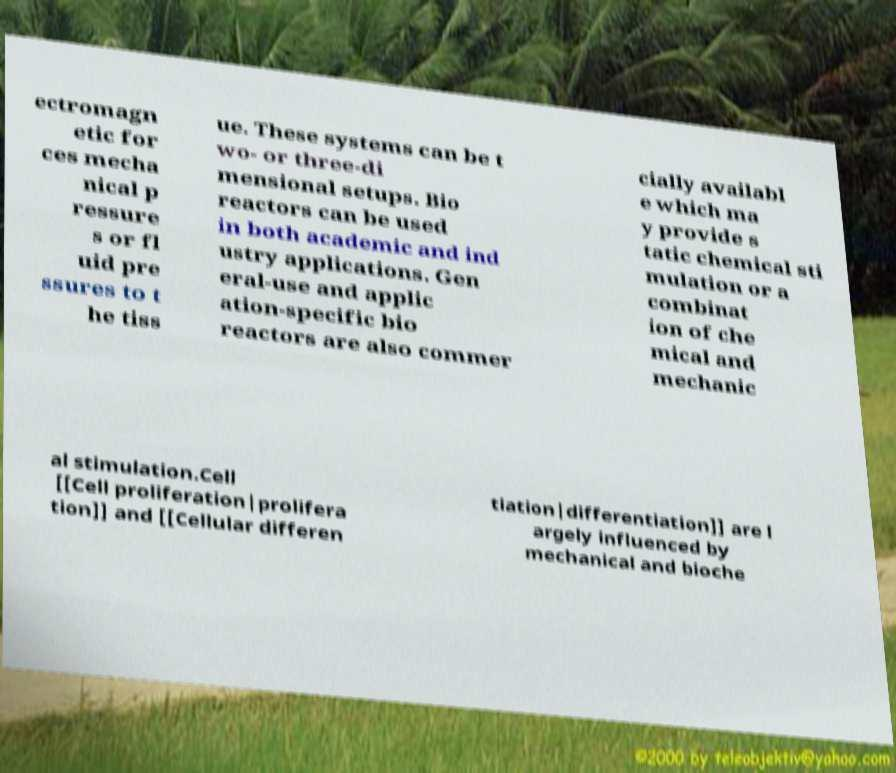Please identify and transcribe the text found in this image. ectromagn etic for ces mecha nical p ressure s or fl uid pre ssures to t he tiss ue. These systems can be t wo- or three-di mensional setups. Bio reactors can be used in both academic and ind ustry applications. Gen eral-use and applic ation-specific bio reactors are also commer cially availabl e which ma y provide s tatic chemical sti mulation or a combinat ion of che mical and mechanic al stimulation.Cell [[Cell proliferation|prolifera tion]] and [[Cellular differen tiation|differentiation]] are l argely influenced by mechanical and bioche 